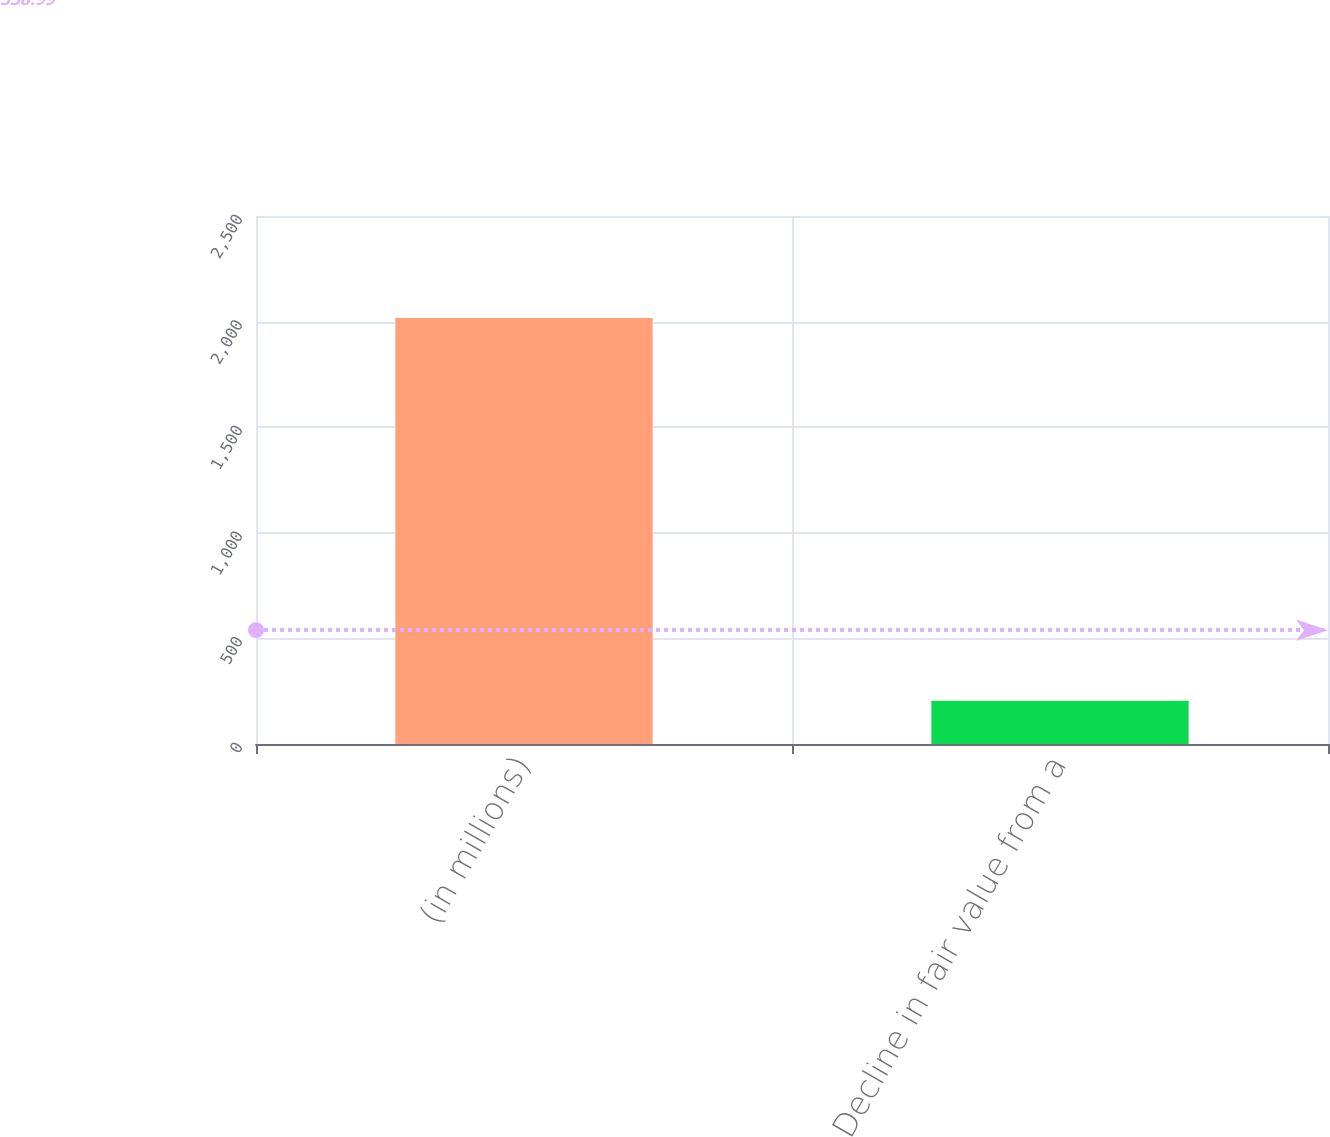<chart> <loc_0><loc_0><loc_500><loc_500><bar_chart><fcel>(in millions)<fcel>Decline in fair value from a<nl><fcel>2017<fcel>205.3<nl></chart> 